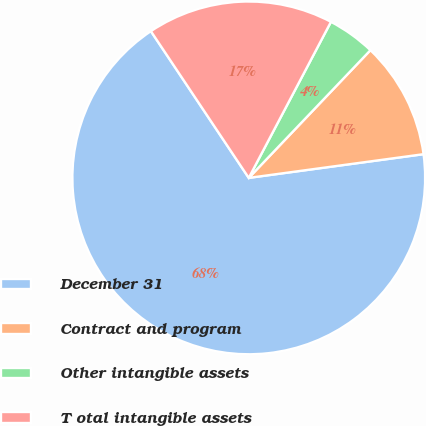Convert chart. <chart><loc_0><loc_0><loc_500><loc_500><pie_chart><fcel>December 31<fcel>Contract and program<fcel>Other intangible assets<fcel>T otal intangible assets<nl><fcel>67.79%<fcel>10.74%<fcel>4.4%<fcel>17.08%<nl></chart> 